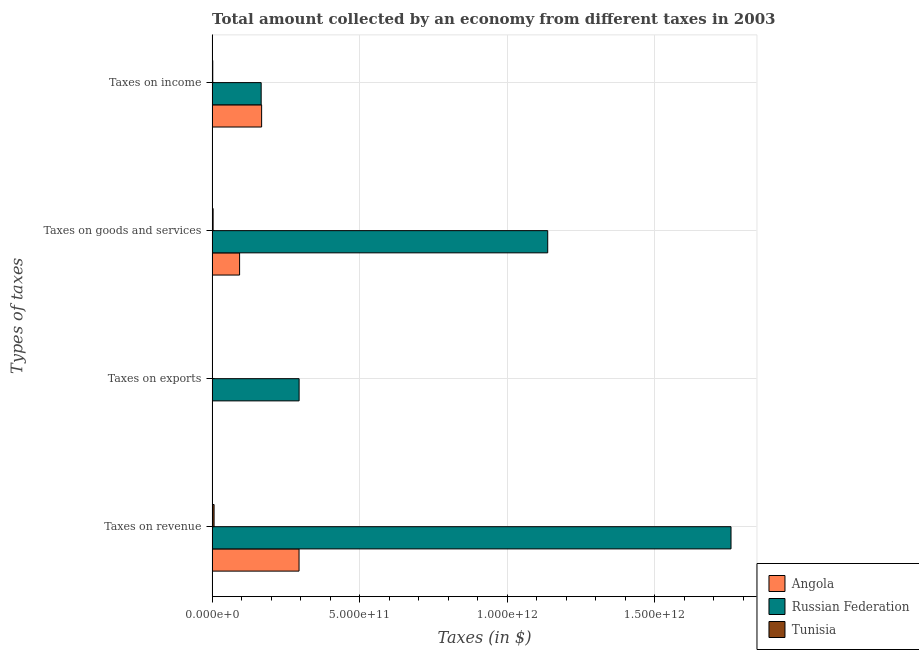How many different coloured bars are there?
Make the answer very short. 3. How many groups of bars are there?
Provide a succinct answer. 4. Are the number of bars on each tick of the Y-axis equal?
Make the answer very short. Yes. How many bars are there on the 2nd tick from the bottom?
Make the answer very short. 3. What is the label of the 3rd group of bars from the top?
Offer a terse response. Taxes on exports. What is the amount collected as tax on goods in Tunisia?
Ensure brevity in your answer.  3.36e+09. Across all countries, what is the maximum amount collected as tax on income?
Make the answer very short. 1.68e+11. Across all countries, what is the minimum amount collected as tax on income?
Make the answer very short. 2.18e+09. In which country was the amount collected as tax on exports maximum?
Offer a very short reply. Russian Federation. In which country was the amount collected as tax on goods minimum?
Your response must be concise. Tunisia. What is the total amount collected as tax on income in the graph?
Ensure brevity in your answer.  3.36e+11. What is the difference between the amount collected as tax on exports in Russian Federation and that in Tunisia?
Provide a short and direct response. 2.95e+11. What is the difference between the amount collected as tax on income in Angola and the amount collected as tax on exports in Tunisia?
Give a very brief answer. 1.68e+11. What is the average amount collected as tax on exports per country?
Provide a succinct answer. 9.84e+1. What is the difference between the amount collected as tax on income and amount collected as tax on revenue in Tunisia?
Provide a short and direct response. -4.45e+09. In how many countries, is the amount collected as tax on exports greater than 900000000000 $?
Your answer should be compact. 0. What is the ratio of the amount collected as tax on exports in Angola to that in Tunisia?
Your answer should be compact. 48.69. What is the difference between the highest and the second highest amount collected as tax on goods?
Give a very brief answer. 1.04e+12. What is the difference between the highest and the lowest amount collected as tax on goods?
Ensure brevity in your answer.  1.13e+12. Is the sum of the amount collected as tax on revenue in Tunisia and Angola greater than the maximum amount collected as tax on exports across all countries?
Provide a short and direct response. Yes. Is it the case that in every country, the sum of the amount collected as tax on revenue and amount collected as tax on exports is greater than the sum of amount collected as tax on goods and amount collected as tax on income?
Your answer should be very brief. No. What does the 1st bar from the top in Taxes on revenue represents?
Make the answer very short. Tunisia. What does the 3rd bar from the bottom in Taxes on exports represents?
Keep it short and to the point. Tunisia. How many countries are there in the graph?
Give a very brief answer. 3. What is the difference between two consecutive major ticks on the X-axis?
Your response must be concise. 5.00e+11. Does the graph contain any zero values?
Give a very brief answer. No. Where does the legend appear in the graph?
Provide a short and direct response. Bottom right. How many legend labels are there?
Your response must be concise. 3. What is the title of the graph?
Give a very brief answer. Total amount collected by an economy from different taxes in 2003. Does "Mongolia" appear as one of the legend labels in the graph?
Your answer should be compact. No. What is the label or title of the X-axis?
Offer a terse response. Taxes (in $). What is the label or title of the Y-axis?
Provide a short and direct response. Types of taxes. What is the Taxes (in $) in Angola in Taxes on revenue?
Offer a terse response. 2.95e+11. What is the Taxes (in $) of Russian Federation in Taxes on revenue?
Give a very brief answer. 1.76e+12. What is the Taxes (in $) in Tunisia in Taxes on revenue?
Offer a terse response. 6.63e+09. What is the Taxes (in $) of Angola in Taxes on exports?
Ensure brevity in your answer.  4.24e+08. What is the Taxes (in $) in Russian Federation in Taxes on exports?
Offer a terse response. 2.95e+11. What is the Taxes (in $) of Tunisia in Taxes on exports?
Provide a succinct answer. 8.70e+06. What is the Taxes (in $) of Angola in Taxes on goods and services?
Your answer should be very brief. 9.31e+1. What is the Taxes (in $) in Russian Federation in Taxes on goods and services?
Ensure brevity in your answer.  1.14e+12. What is the Taxes (in $) in Tunisia in Taxes on goods and services?
Your response must be concise. 3.36e+09. What is the Taxes (in $) in Angola in Taxes on income?
Offer a terse response. 1.68e+11. What is the Taxes (in $) of Russian Federation in Taxes on income?
Offer a very short reply. 1.66e+11. What is the Taxes (in $) of Tunisia in Taxes on income?
Keep it short and to the point. 2.18e+09. Across all Types of taxes, what is the maximum Taxes (in $) of Angola?
Your response must be concise. 2.95e+11. Across all Types of taxes, what is the maximum Taxes (in $) in Russian Federation?
Provide a short and direct response. 1.76e+12. Across all Types of taxes, what is the maximum Taxes (in $) of Tunisia?
Keep it short and to the point. 6.63e+09. Across all Types of taxes, what is the minimum Taxes (in $) of Angola?
Give a very brief answer. 4.24e+08. Across all Types of taxes, what is the minimum Taxes (in $) of Russian Federation?
Provide a short and direct response. 1.66e+11. Across all Types of taxes, what is the minimum Taxes (in $) in Tunisia?
Provide a short and direct response. 8.70e+06. What is the total Taxes (in $) of Angola in the graph?
Your answer should be compact. 5.56e+11. What is the total Taxes (in $) in Russian Federation in the graph?
Provide a short and direct response. 3.36e+12. What is the total Taxes (in $) in Tunisia in the graph?
Your answer should be very brief. 1.22e+1. What is the difference between the Taxes (in $) in Angola in Taxes on revenue and that in Taxes on exports?
Provide a succinct answer. 2.94e+11. What is the difference between the Taxes (in $) in Russian Federation in Taxes on revenue and that in Taxes on exports?
Offer a very short reply. 1.46e+12. What is the difference between the Taxes (in $) of Tunisia in Taxes on revenue and that in Taxes on exports?
Provide a succinct answer. 6.62e+09. What is the difference between the Taxes (in $) of Angola in Taxes on revenue and that in Taxes on goods and services?
Keep it short and to the point. 2.01e+11. What is the difference between the Taxes (in $) in Russian Federation in Taxes on revenue and that in Taxes on goods and services?
Your response must be concise. 6.21e+11. What is the difference between the Taxes (in $) in Tunisia in Taxes on revenue and that in Taxes on goods and services?
Provide a succinct answer. 3.27e+09. What is the difference between the Taxes (in $) of Angola in Taxes on revenue and that in Taxes on income?
Give a very brief answer. 1.27e+11. What is the difference between the Taxes (in $) of Russian Federation in Taxes on revenue and that in Taxes on income?
Your response must be concise. 1.59e+12. What is the difference between the Taxes (in $) in Tunisia in Taxes on revenue and that in Taxes on income?
Offer a very short reply. 4.45e+09. What is the difference between the Taxes (in $) of Angola in Taxes on exports and that in Taxes on goods and services?
Ensure brevity in your answer.  -9.27e+1. What is the difference between the Taxes (in $) in Russian Federation in Taxes on exports and that in Taxes on goods and services?
Ensure brevity in your answer.  -8.43e+11. What is the difference between the Taxes (in $) of Tunisia in Taxes on exports and that in Taxes on goods and services?
Offer a terse response. -3.35e+09. What is the difference between the Taxes (in $) of Angola in Taxes on exports and that in Taxes on income?
Your answer should be very brief. -1.67e+11. What is the difference between the Taxes (in $) in Russian Federation in Taxes on exports and that in Taxes on income?
Make the answer very short. 1.29e+11. What is the difference between the Taxes (in $) of Tunisia in Taxes on exports and that in Taxes on income?
Your response must be concise. -2.17e+09. What is the difference between the Taxes (in $) of Angola in Taxes on goods and services and that in Taxes on income?
Offer a terse response. -7.46e+1. What is the difference between the Taxes (in $) in Russian Federation in Taxes on goods and services and that in Taxes on income?
Your answer should be compact. 9.71e+11. What is the difference between the Taxes (in $) of Tunisia in Taxes on goods and services and that in Taxes on income?
Your response must be concise. 1.18e+09. What is the difference between the Taxes (in $) in Angola in Taxes on revenue and the Taxes (in $) in Russian Federation in Taxes on exports?
Keep it short and to the point. -1.94e+08. What is the difference between the Taxes (in $) in Angola in Taxes on revenue and the Taxes (in $) in Tunisia in Taxes on exports?
Keep it short and to the point. 2.95e+11. What is the difference between the Taxes (in $) of Russian Federation in Taxes on revenue and the Taxes (in $) of Tunisia in Taxes on exports?
Make the answer very short. 1.76e+12. What is the difference between the Taxes (in $) in Angola in Taxes on revenue and the Taxes (in $) in Russian Federation in Taxes on goods and services?
Give a very brief answer. -8.43e+11. What is the difference between the Taxes (in $) of Angola in Taxes on revenue and the Taxes (in $) of Tunisia in Taxes on goods and services?
Offer a very short reply. 2.91e+11. What is the difference between the Taxes (in $) of Russian Federation in Taxes on revenue and the Taxes (in $) of Tunisia in Taxes on goods and services?
Your answer should be compact. 1.76e+12. What is the difference between the Taxes (in $) of Angola in Taxes on revenue and the Taxes (in $) of Russian Federation in Taxes on income?
Make the answer very short. 1.28e+11. What is the difference between the Taxes (in $) of Angola in Taxes on revenue and the Taxes (in $) of Tunisia in Taxes on income?
Offer a very short reply. 2.92e+11. What is the difference between the Taxes (in $) of Russian Federation in Taxes on revenue and the Taxes (in $) of Tunisia in Taxes on income?
Your answer should be very brief. 1.76e+12. What is the difference between the Taxes (in $) in Angola in Taxes on exports and the Taxes (in $) in Russian Federation in Taxes on goods and services?
Offer a terse response. -1.14e+12. What is the difference between the Taxes (in $) in Angola in Taxes on exports and the Taxes (in $) in Tunisia in Taxes on goods and services?
Provide a short and direct response. -2.94e+09. What is the difference between the Taxes (in $) in Russian Federation in Taxes on exports and the Taxes (in $) in Tunisia in Taxes on goods and services?
Your answer should be very brief. 2.91e+11. What is the difference between the Taxes (in $) in Angola in Taxes on exports and the Taxes (in $) in Russian Federation in Taxes on income?
Your answer should be compact. -1.66e+11. What is the difference between the Taxes (in $) in Angola in Taxes on exports and the Taxes (in $) in Tunisia in Taxes on income?
Make the answer very short. -1.75e+09. What is the difference between the Taxes (in $) in Russian Federation in Taxes on exports and the Taxes (in $) in Tunisia in Taxes on income?
Offer a very short reply. 2.93e+11. What is the difference between the Taxes (in $) of Angola in Taxes on goods and services and the Taxes (in $) of Russian Federation in Taxes on income?
Make the answer very short. -7.31e+1. What is the difference between the Taxes (in $) of Angola in Taxes on goods and services and the Taxes (in $) of Tunisia in Taxes on income?
Make the answer very short. 9.09e+1. What is the difference between the Taxes (in $) of Russian Federation in Taxes on goods and services and the Taxes (in $) of Tunisia in Taxes on income?
Keep it short and to the point. 1.14e+12. What is the average Taxes (in $) of Angola per Types of taxes?
Provide a succinct answer. 1.39e+11. What is the average Taxes (in $) of Russian Federation per Types of taxes?
Give a very brief answer. 8.39e+11. What is the average Taxes (in $) of Tunisia per Types of taxes?
Keep it short and to the point. 3.04e+09. What is the difference between the Taxes (in $) in Angola and Taxes (in $) in Russian Federation in Taxes on revenue?
Your answer should be compact. -1.46e+12. What is the difference between the Taxes (in $) of Angola and Taxes (in $) of Tunisia in Taxes on revenue?
Your answer should be compact. 2.88e+11. What is the difference between the Taxes (in $) in Russian Federation and Taxes (in $) in Tunisia in Taxes on revenue?
Give a very brief answer. 1.75e+12. What is the difference between the Taxes (in $) of Angola and Taxes (in $) of Russian Federation in Taxes on exports?
Your answer should be compact. -2.94e+11. What is the difference between the Taxes (in $) in Angola and Taxes (in $) in Tunisia in Taxes on exports?
Provide a short and direct response. 4.15e+08. What is the difference between the Taxes (in $) of Russian Federation and Taxes (in $) of Tunisia in Taxes on exports?
Ensure brevity in your answer.  2.95e+11. What is the difference between the Taxes (in $) in Angola and Taxes (in $) in Russian Federation in Taxes on goods and services?
Your answer should be very brief. -1.04e+12. What is the difference between the Taxes (in $) in Angola and Taxes (in $) in Tunisia in Taxes on goods and services?
Your answer should be very brief. 8.98e+1. What is the difference between the Taxes (in $) in Russian Federation and Taxes (in $) in Tunisia in Taxes on goods and services?
Make the answer very short. 1.13e+12. What is the difference between the Taxes (in $) of Angola and Taxes (in $) of Russian Federation in Taxes on income?
Your response must be concise. 1.52e+09. What is the difference between the Taxes (in $) of Angola and Taxes (in $) of Tunisia in Taxes on income?
Offer a very short reply. 1.66e+11. What is the difference between the Taxes (in $) of Russian Federation and Taxes (in $) of Tunisia in Taxes on income?
Offer a very short reply. 1.64e+11. What is the ratio of the Taxes (in $) in Angola in Taxes on revenue to that in Taxes on exports?
Your answer should be compact. 695.46. What is the ratio of the Taxes (in $) in Russian Federation in Taxes on revenue to that in Taxes on exports?
Offer a terse response. 5.97. What is the ratio of the Taxes (in $) of Tunisia in Taxes on revenue to that in Taxes on exports?
Offer a very short reply. 762.16. What is the ratio of the Taxes (in $) of Angola in Taxes on revenue to that in Taxes on goods and services?
Ensure brevity in your answer.  3.16. What is the ratio of the Taxes (in $) of Russian Federation in Taxes on revenue to that in Taxes on goods and services?
Ensure brevity in your answer.  1.55. What is the ratio of the Taxes (in $) of Tunisia in Taxes on revenue to that in Taxes on goods and services?
Make the answer very short. 1.97. What is the ratio of the Taxes (in $) in Angola in Taxes on revenue to that in Taxes on income?
Give a very brief answer. 1.76. What is the ratio of the Taxes (in $) of Russian Federation in Taxes on revenue to that in Taxes on income?
Offer a very short reply. 10.58. What is the ratio of the Taxes (in $) in Tunisia in Taxes on revenue to that in Taxes on income?
Make the answer very short. 3.05. What is the ratio of the Taxes (in $) of Angola in Taxes on exports to that in Taxes on goods and services?
Keep it short and to the point. 0. What is the ratio of the Taxes (in $) of Russian Federation in Taxes on exports to that in Taxes on goods and services?
Offer a terse response. 0.26. What is the ratio of the Taxes (in $) in Tunisia in Taxes on exports to that in Taxes on goods and services?
Offer a very short reply. 0. What is the ratio of the Taxes (in $) of Angola in Taxes on exports to that in Taxes on income?
Keep it short and to the point. 0. What is the ratio of the Taxes (in $) in Russian Federation in Taxes on exports to that in Taxes on income?
Ensure brevity in your answer.  1.77. What is the ratio of the Taxes (in $) in Tunisia in Taxes on exports to that in Taxes on income?
Provide a short and direct response. 0. What is the ratio of the Taxes (in $) in Angola in Taxes on goods and services to that in Taxes on income?
Keep it short and to the point. 0.56. What is the ratio of the Taxes (in $) in Russian Federation in Taxes on goods and services to that in Taxes on income?
Offer a terse response. 6.84. What is the ratio of the Taxes (in $) in Tunisia in Taxes on goods and services to that in Taxes on income?
Provide a succinct answer. 1.54. What is the difference between the highest and the second highest Taxes (in $) in Angola?
Your response must be concise. 1.27e+11. What is the difference between the highest and the second highest Taxes (in $) of Russian Federation?
Give a very brief answer. 6.21e+11. What is the difference between the highest and the second highest Taxes (in $) of Tunisia?
Offer a terse response. 3.27e+09. What is the difference between the highest and the lowest Taxes (in $) in Angola?
Offer a terse response. 2.94e+11. What is the difference between the highest and the lowest Taxes (in $) in Russian Federation?
Give a very brief answer. 1.59e+12. What is the difference between the highest and the lowest Taxes (in $) of Tunisia?
Make the answer very short. 6.62e+09. 